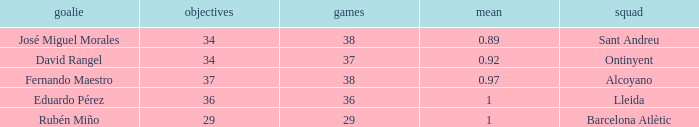What is the highest Average, when Goals is "34", and when Matches is less than 37? None. 